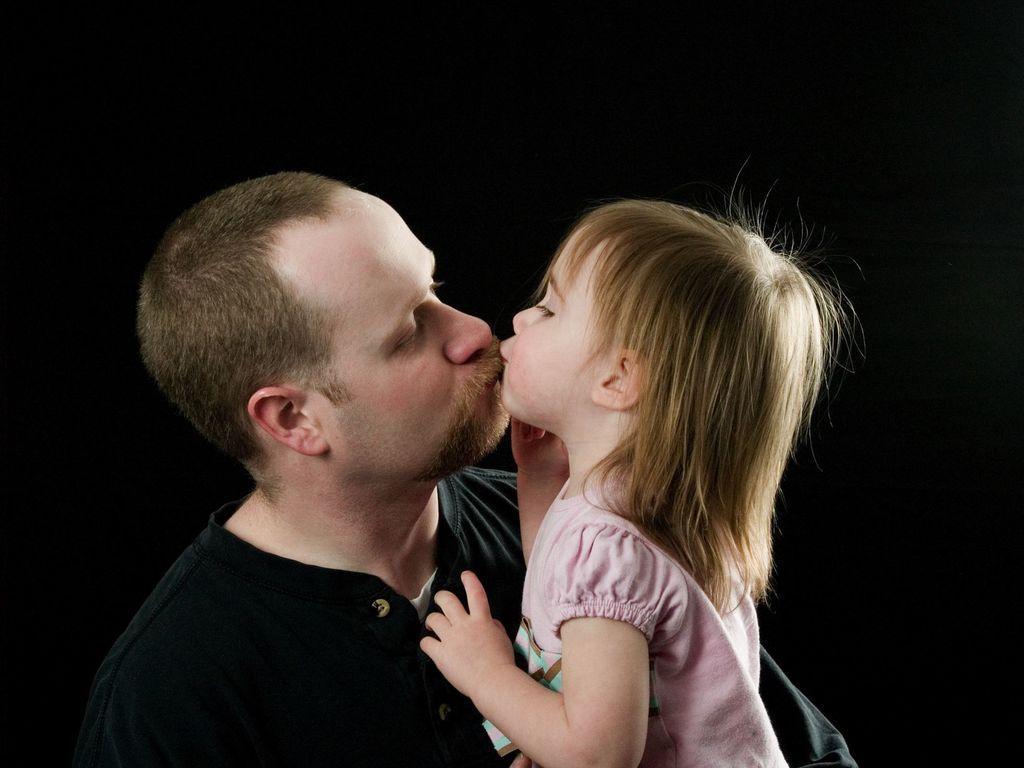Can you describe this image briefly? In this picture there is a man who is wearing black t-shirt. He is holding a girl. She is wearing pink color dress. At the top we can see the darkness. 